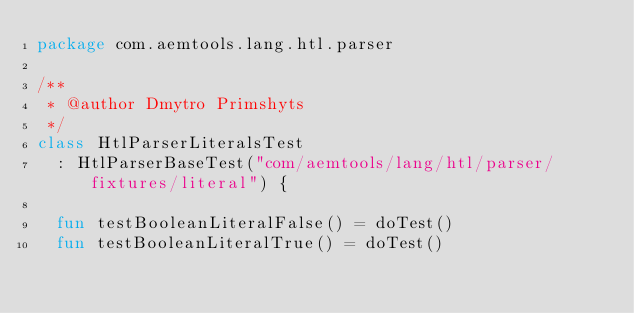<code> <loc_0><loc_0><loc_500><loc_500><_Kotlin_>package com.aemtools.lang.htl.parser

/**
 * @author Dmytro Primshyts
 */
class HtlParserLiteralsTest
  : HtlParserBaseTest("com/aemtools/lang/htl/parser/fixtures/literal") {

  fun testBooleanLiteralFalse() = doTest()
  fun testBooleanLiteralTrue() = doTest()</code> 